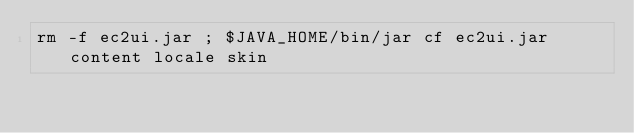<code> <loc_0><loc_0><loc_500><loc_500><_Bash_>rm -f ec2ui.jar ; $JAVA_HOME/bin/jar cf ec2ui.jar content locale skin
</code> 